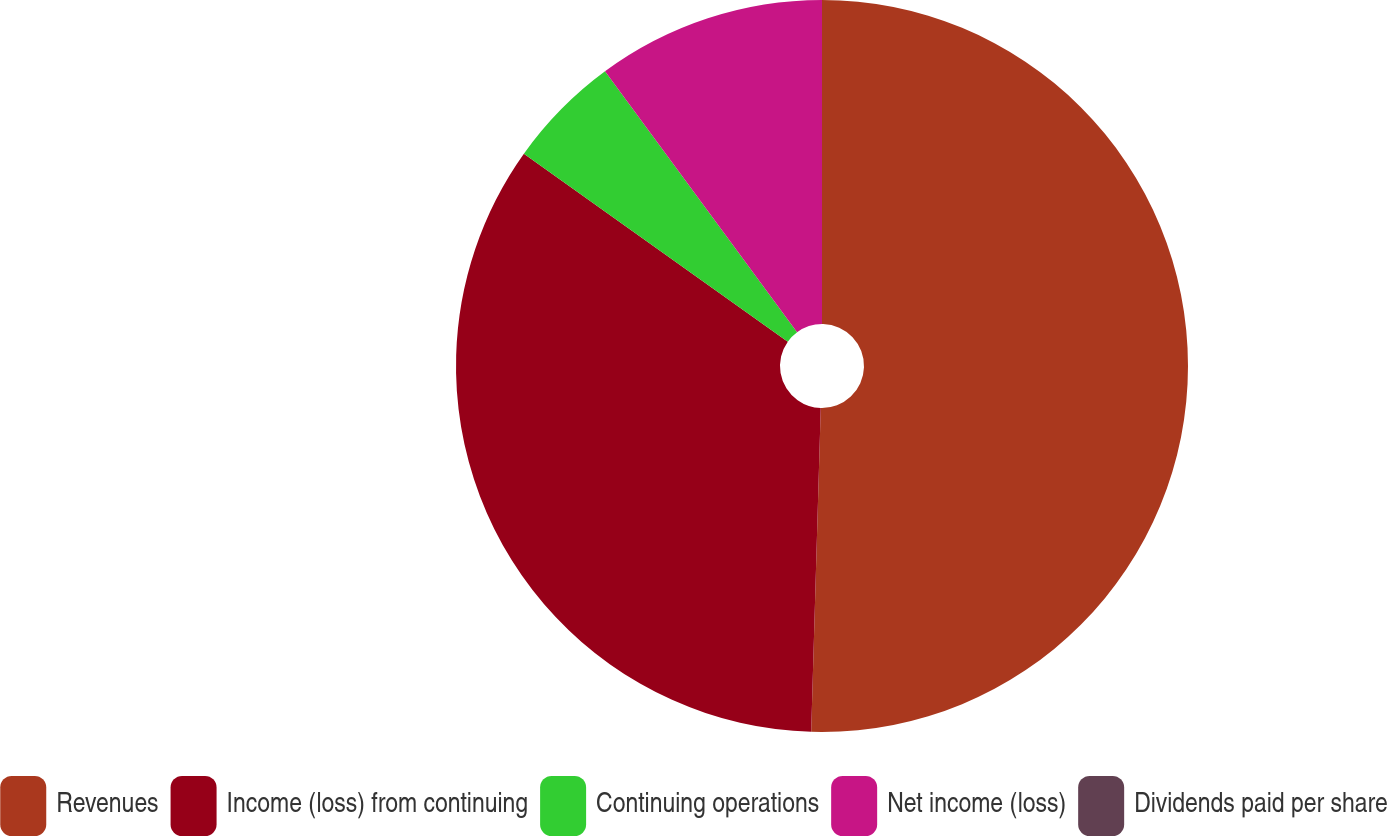Convert chart. <chart><loc_0><loc_0><loc_500><loc_500><pie_chart><fcel>Revenues<fcel>Income (loss) from continuing<fcel>Continuing operations<fcel>Net income (loss)<fcel>Dividends paid per share<nl><fcel>50.47%<fcel>34.38%<fcel>5.05%<fcel>10.1%<fcel>0.0%<nl></chart> 